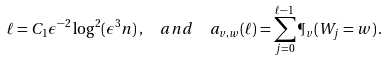<formula> <loc_0><loc_0><loc_500><loc_500>\ell & = C _ { 1 } \epsilon ^ { - 2 } \log ^ { 2 } ( \epsilon ^ { 3 } n ) \, , \quad a n d \quad a _ { v , w } ( \ell ) = \sum _ { j = 0 } ^ { \ell - 1 } \P _ { v } ( W _ { j } = w ) \, .</formula> 